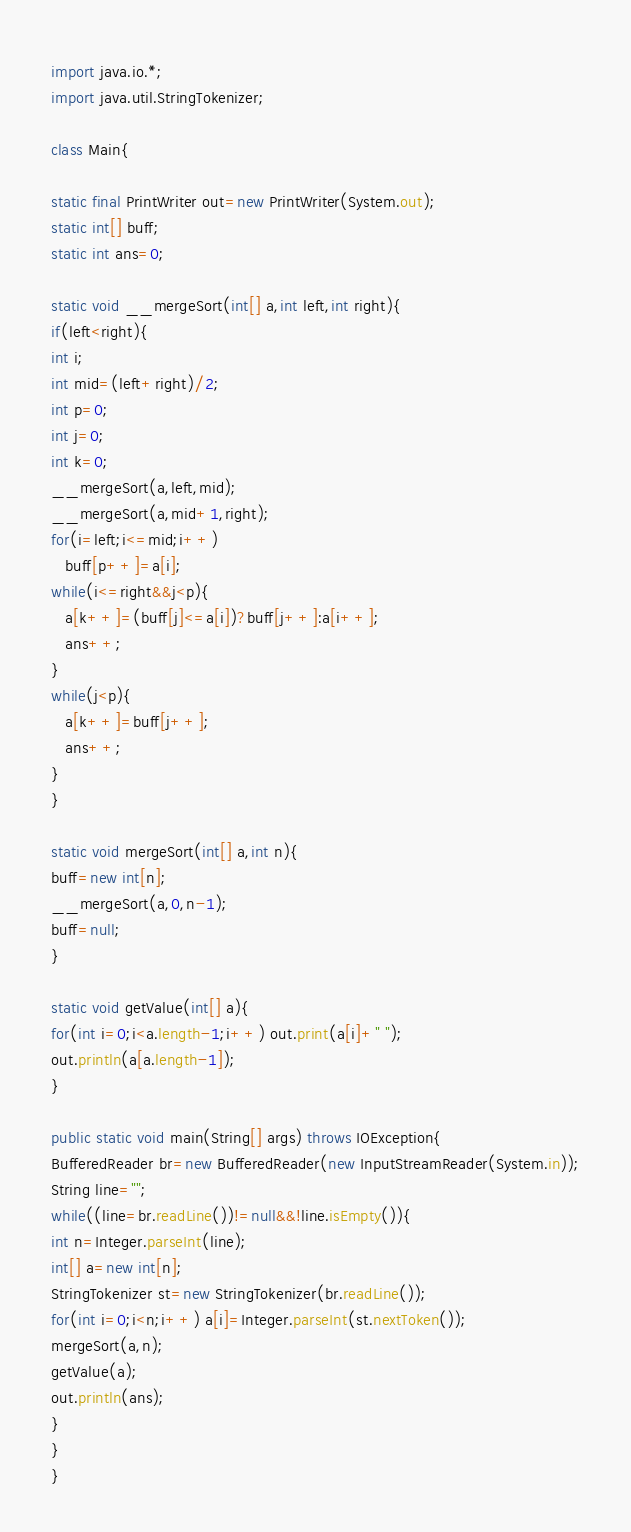<code> <loc_0><loc_0><loc_500><loc_500><_Java_>import java.io.*;
import java.util.StringTokenizer;

class Main{

static final PrintWriter out=new PrintWriter(System.out);
static int[] buff;
static int ans=0;

static void __mergeSort(int[] a,int left,int right){
if(left<right){
int i;
int mid=(left+right)/2;
int p=0;
int j=0;
int k=0;
__mergeSort(a,left,mid);
__mergeSort(a,mid+1,right);
for(i=left;i<=mid;i++)
   buff[p++]=a[i];
while(i<=right&&j<p){
   a[k++]=(buff[j]<=a[i])?buff[j++]:a[i++];
   ans++;
}
while(j<p){
   a[k++]=buff[j++];
   ans++;
}
}

static void mergeSort(int[] a,int n){
buff=new int[n];
__mergeSort(a,0,n-1);
buff=null;
}

static void getValue(int[] a){
for(int i=0;i<a.length-1;i++) out.print(a[i]+" ");
out.println(a[a.length-1]);
}

public static void main(String[] args) throws IOException{
BufferedReader br=new BufferedReader(new InputStreamReader(System.in));
String line="";
while((line=br.readLine())!=null&&!line.isEmpty()){
int n=Integer.parseInt(line);
int[] a=new int[n];
StringTokenizer st=new StringTokenizer(br.readLine());
for(int i=0;i<n;i++) a[i]=Integer.parseInt(st.nextToken());
mergeSort(a,n);
getValue(a);
out.println(ans);
}
}
}</code> 